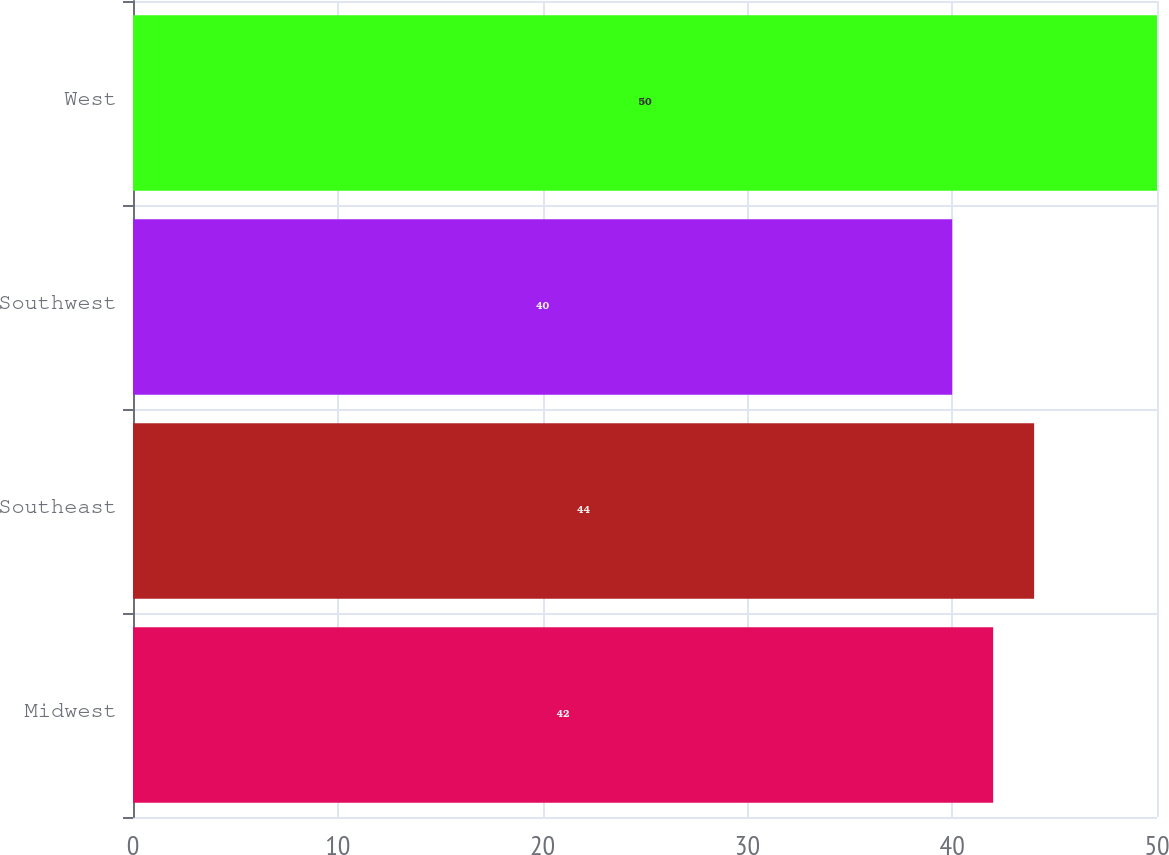<chart> <loc_0><loc_0><loc_500><loc_500><bar_chart><fcel>Midwest<fcel>Southeast<fcel>Southwest<fcel>West<nl><fcel>42<fcel>44<fcel>40<fcel>50<nl></chart> 